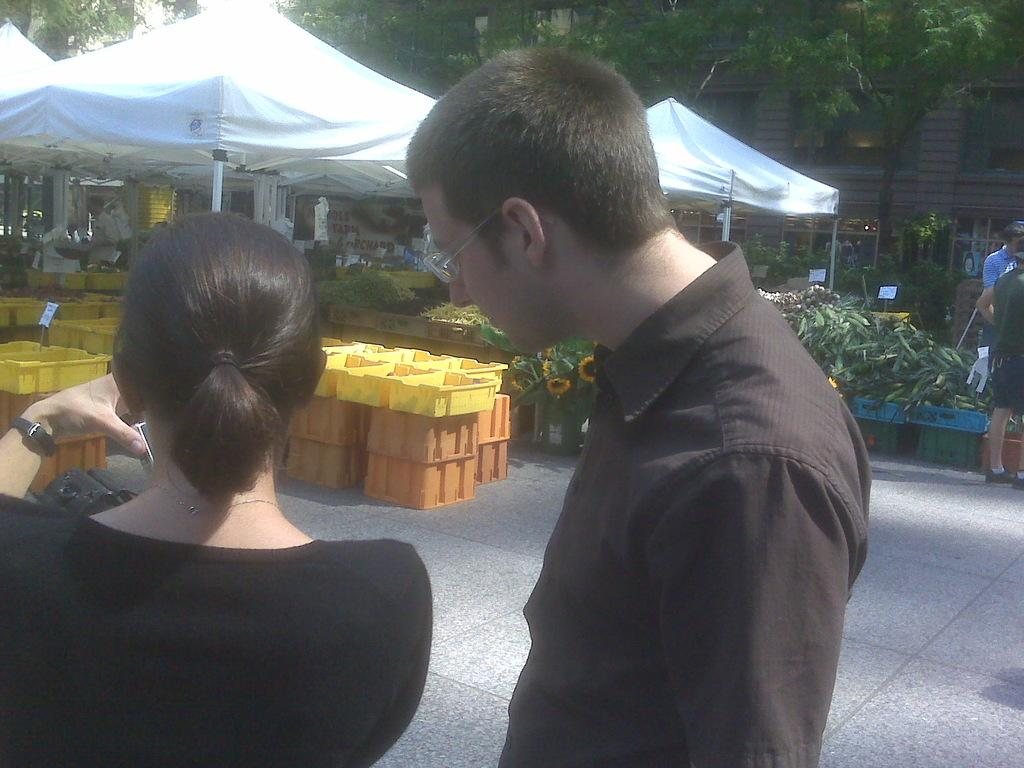How many people are present in the image? There are two persons in the image. What objects can be seen in the image? There are baskets, plants, flowers, tents, and boards in the image. What type of vegetation is present in the image? There are plants and flowers in the image. What structures can be seen in the background of the image? There are trees and a building in the background of the image. What type of wax can be seen melting on the library floor in the image? There is no wax or library present in the image. Is there a band playing music in the image? There is no band or music-related activity depicted in the image. 